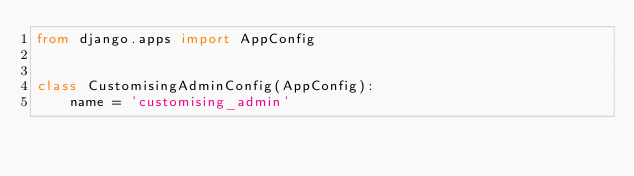<code> <loc_0><loc_0><loc_500><loc_500><_Python_>from django.apps import AppConfig


class CustomisingAdminConfig(AppConfig):
    name = 'customising_admin'
</code> 